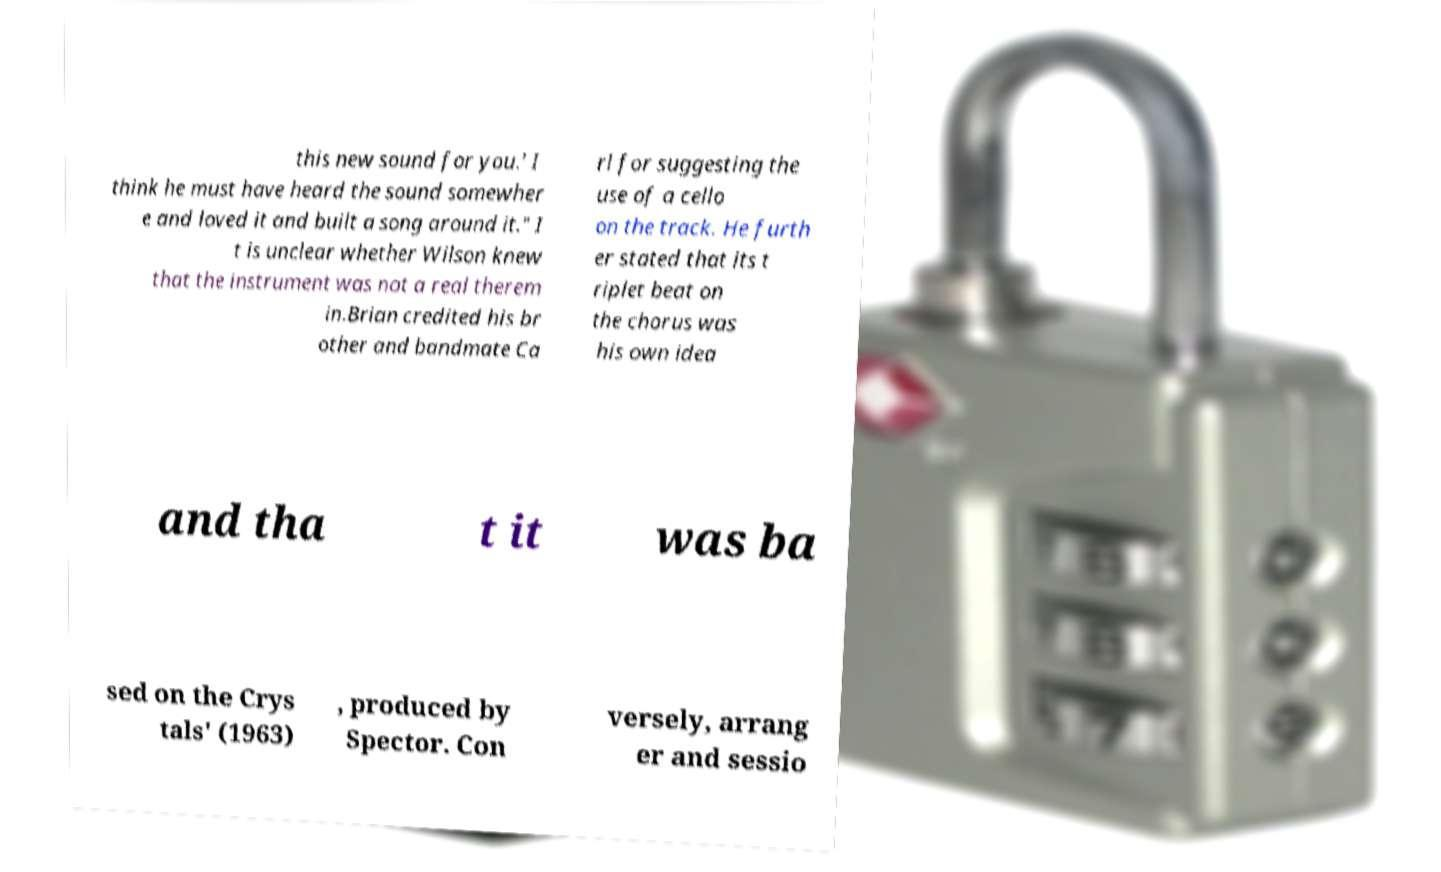Could you assist in decoding the text presented in this image and type it out clearly? this new sound for you.' I think he must have heard the sound somewher e and loved it and built a song around it." I t is unclear whether Wilson knew that the instrument was not a real therem in.Brian credited his br other and bandmate Ca rl for suggesting the use of a cello on the track. He furth er stated that its t riplet beat on the chorus was his own idea and tha t it was ba sed on the Crys tals' (1963) , produced by Spector. Con versely, arrang er and sessio 